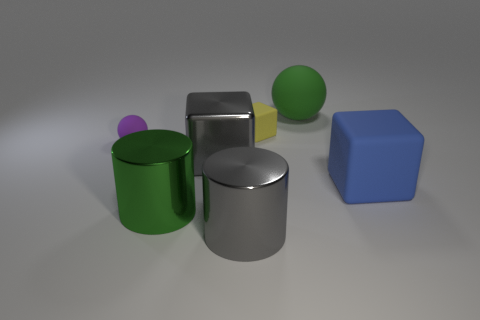There is a purple object that is the same material as the large ball; what shape is it?
Your answer should be compact. Sphere. Are the small sphere and the large gray cylinder made of the same material?
Offer a very short reply. No. Are there fewer rubber blocks that are to the right of the large green cylinder than large cylinders behind the small rubber cube?
Ensure brevity in your answer.  No. What is the size of the metallic object that is the same color as the big ball?
Your answer should be compact. Large. How many shiny cylinders are behind the thing to the left of the big green metal cylinder that is on the left side of the blue cube?
Your answer should be very brief. 0. Do the small matte ball and the big rubber cube have the same color?
Your answer should be very brief. No. Are there any small things that have the same color as the small ball?
Your answer should be compact. No. There is a metal block that is the same size as the green matte thing; what color is it?
Offer a terse response. Gray. Are there any other yellow things that have the same shape as the small yellow matte object?
Your response must be concise. No. There is a rubber cube that is on the left side of the large rubber object in front of the purple thing; are there any small rubber balls to the left of it?
Ensure brevity in your answer.  Yes. 